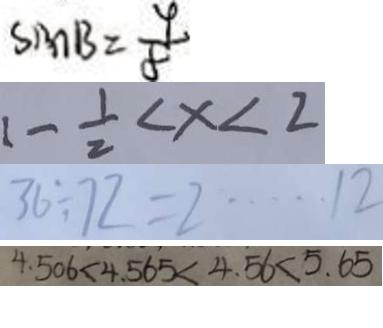Convert formula to latex. <formula><loc_0><loc_0><loc_500><loc_500>\sin B = \frac { 9 } { 8 } 
 1 - \frac { 1 } { 2 } < x < 2 
 3 6 \div 7 2 = 2 \cdots 1 2 
 4 . 5 0 6 < 4 . 5 6 5 < 4 . 5 6 < 5 . 6 5</formula> 